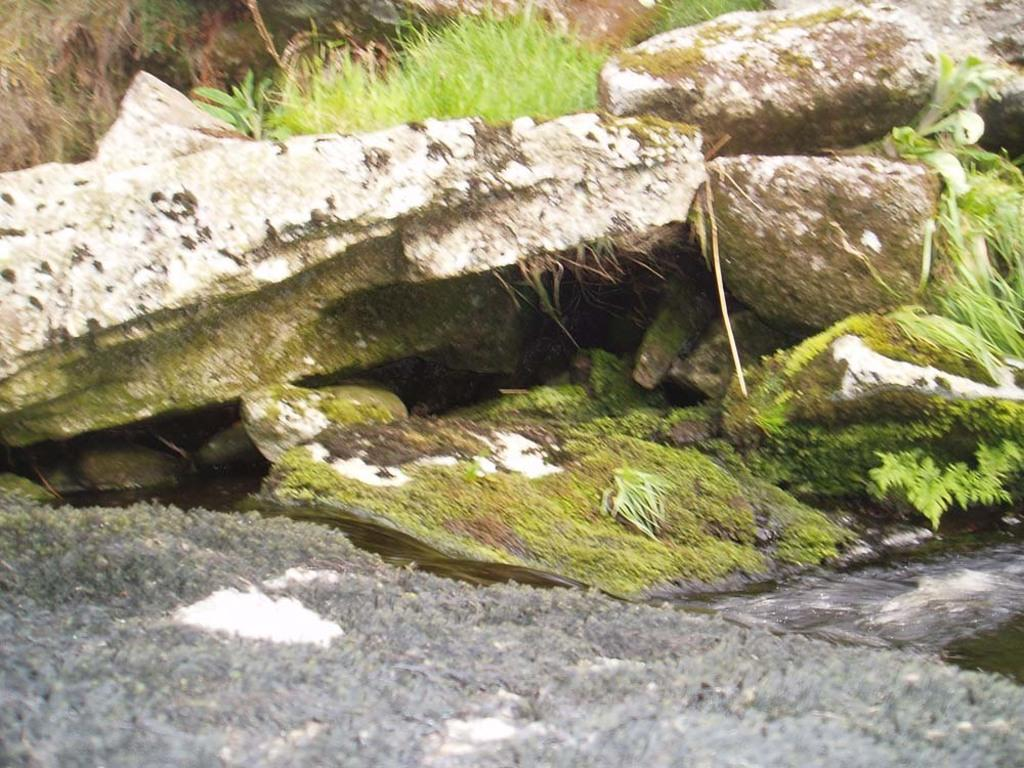What type of natural elements can be seen in the image? There are rocks and grass in the image. Can you describe the texture of the rocks in the image? The texture of the rocks cannot be determined from the image alone. What type of vegetation is present in the image? Grass is present in the image. How many grapes are hanging from the rocks in the image? There are no grapes present in the image; it features rocks and grass. What type of utensil is used to fold the rocks in the image? There is no utensil or folding action present in the image, as rocks are naturally occurring and do not require folding. 